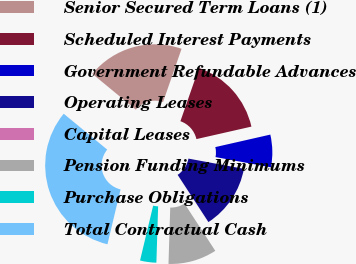Convert chart to OTSL. <chart><loc_0><loc_0><loc_500><loc_500><pie_chart><fcel>Senior Secured Term Loans (1)<fcel>Scheduled Interest Payments<fcel>Government Refundable Advances<fcel>Operating Leases<fcel>Capital Leases<fcel>Pension Funding Minimums<fcel>Purchase Obligations<fcel>Total Contractual Cash<nl><fcel>19.35%<fcel>16.12%<fcel>6.46%<fcel>12.9%<fcel>0.01%<fcel>9.68%<fcel>3.24%<fcel>32.24%<nl></chart> 